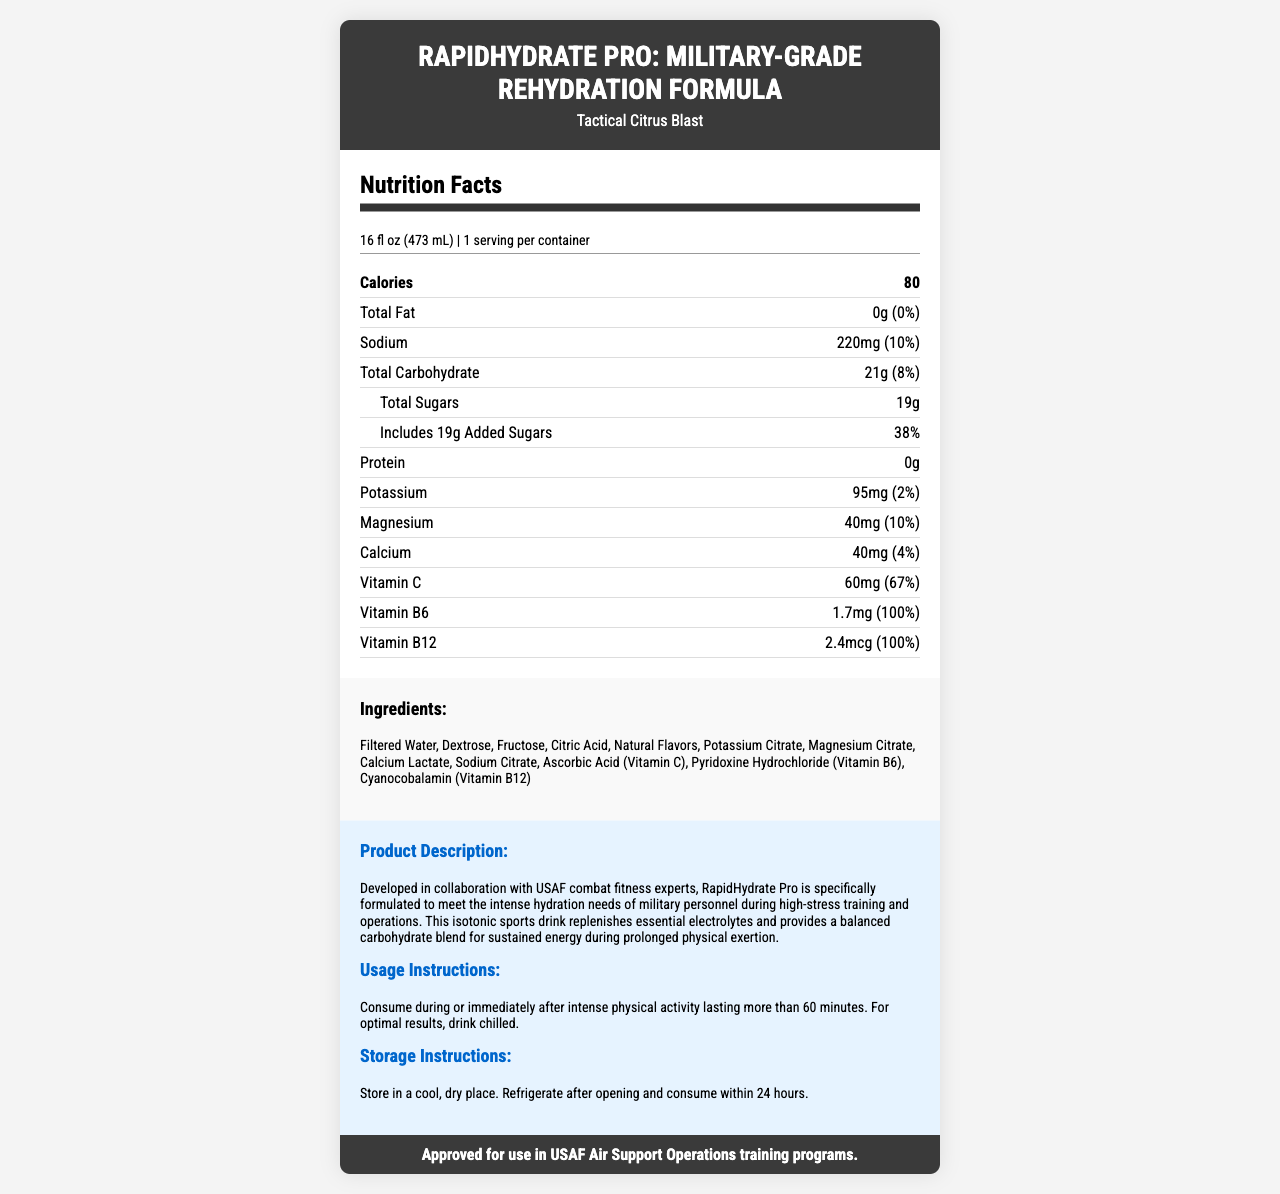what is the serving size for RapidHydrate Pro? The serving size is explicitly stated in the nutrition facts label under 'serving size'.
Answer: 16 fl oz (473 mL) how many grams of total sugars does the product contain? The total sugars are listed as 19g in the nutrition facts section.
Answer: 19g what percentage of the daily value for Vitamin C is in one serving? Vitamin C provides 67% of the daily value as noted in the nutrient row for Vitamin C.
Answer: 67% List one of the minerals included in the drink and its amount. One of the minerals included in the drink is Sodium, and it is listed with the amount of 220mg.
Answer: Sodium: 220mg what is the flavor of RapidHydrate Pro? The flavor was mentioned right after the product name in the title section.
Answer: Tactical Citrus Blast The product should be stored: A. In a warm place B. In a cool, dry place C. In direct sunlight The storage instructions specify "Store in a cool, dry place."
Answer: B Which vitamin in the product provides 100% of the daily value? A. Vitamin C B. Vitamin B6 C. Vitamin B12 D. All of the above Both Vitamin B6 and Vitamin B12 provide 100% of the daily value.
Answer: D What is the primary purpose of RapidHydrate Pro as described in the product description? The description specifies that the product is formulated for rapid rehydration during intense physical training.
Answer: Rapid rehydration during intense physical training Does this product contain any protein? The nutrient row for Protein lists its amount as 0g.
Answer: No Summarize the main highlights of RapidHydrate Pro: Military-Grade Rehydration Formula. The detailed description, nutrient facts, and endorsement section collectively provide these highlights.
Answer: The main highlights of the product are that it's geared towards rapid rehydration for military personnel during intense physical training, contains essential electrolytes and vitamins, provides a balanced carbohydrate blend, and is endorsed for use in USAF Air Support Operations training programs. How does the magnesium content in the product compare to its daily value? The magnesium content is listed as 40mg, providing 10% of the daily value.
Answer: 40mg, which is 10% of the daily value What are some of the additional ingredients in RapidHydrate Pro? List at least three. These ingredients are listed under the 'Ingredients' section.
Answer: Dextrose, Fructose, Citric Acid What is the source of carbohydrates in the drink? The ingredients list includes Dextrose and Fructose, which are sources of carbohydrates.
Answer: Dextrose, Fructose Does the product contain any allergens? The information about allergens is not provided in the document.
Answer: Not enough information For how long should you consume the product after opening it? The storage instructions state to consume the product within 24 hours of opening.
Answer: Within 24 hours What can be inferred about the calorie content relative to its serving size? The calorie content is clearly listed as 80 calories, and the serving size is 16 fl oz.
Answer: The product contains 80 calories per 16 fl oz serving. Who endorses the use of RapidHydrate Pro? The endorsement section specifies that it is approved for use in USAF Air Support Operations training programs.
Answer: USAF Air Support Operations training programs 